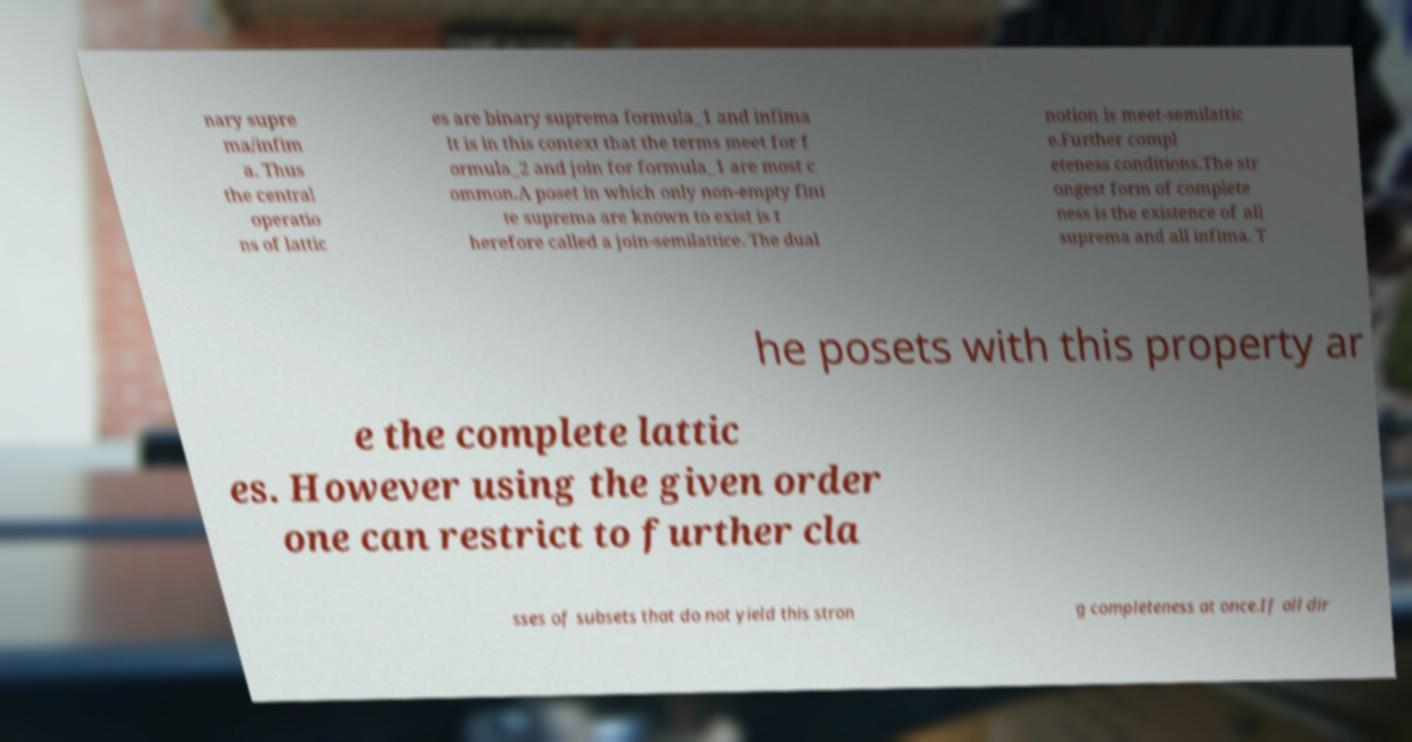Please identify and transcribe the text found in this image. nary supre ma/infim a. Thus the central operatio ns of lattic es are binary suprema formula_1 and infima It is in this context that the terms meet for f ormula_2 and join for formula_1 are most c ommon.A poset in which only non-empty fini te suprema are known to exist is t herefore called a join-semilattice. The dual notion is meet-semilattic e.Further compl eteness conditions.The str ongest form of complete ness is the existence of all suprema and all infima. T he posets with this property ar e the complete lattic es. However using the given order one can restrict to further cla sses of subsets that do not yield this stron g completeness at once.If all dir 